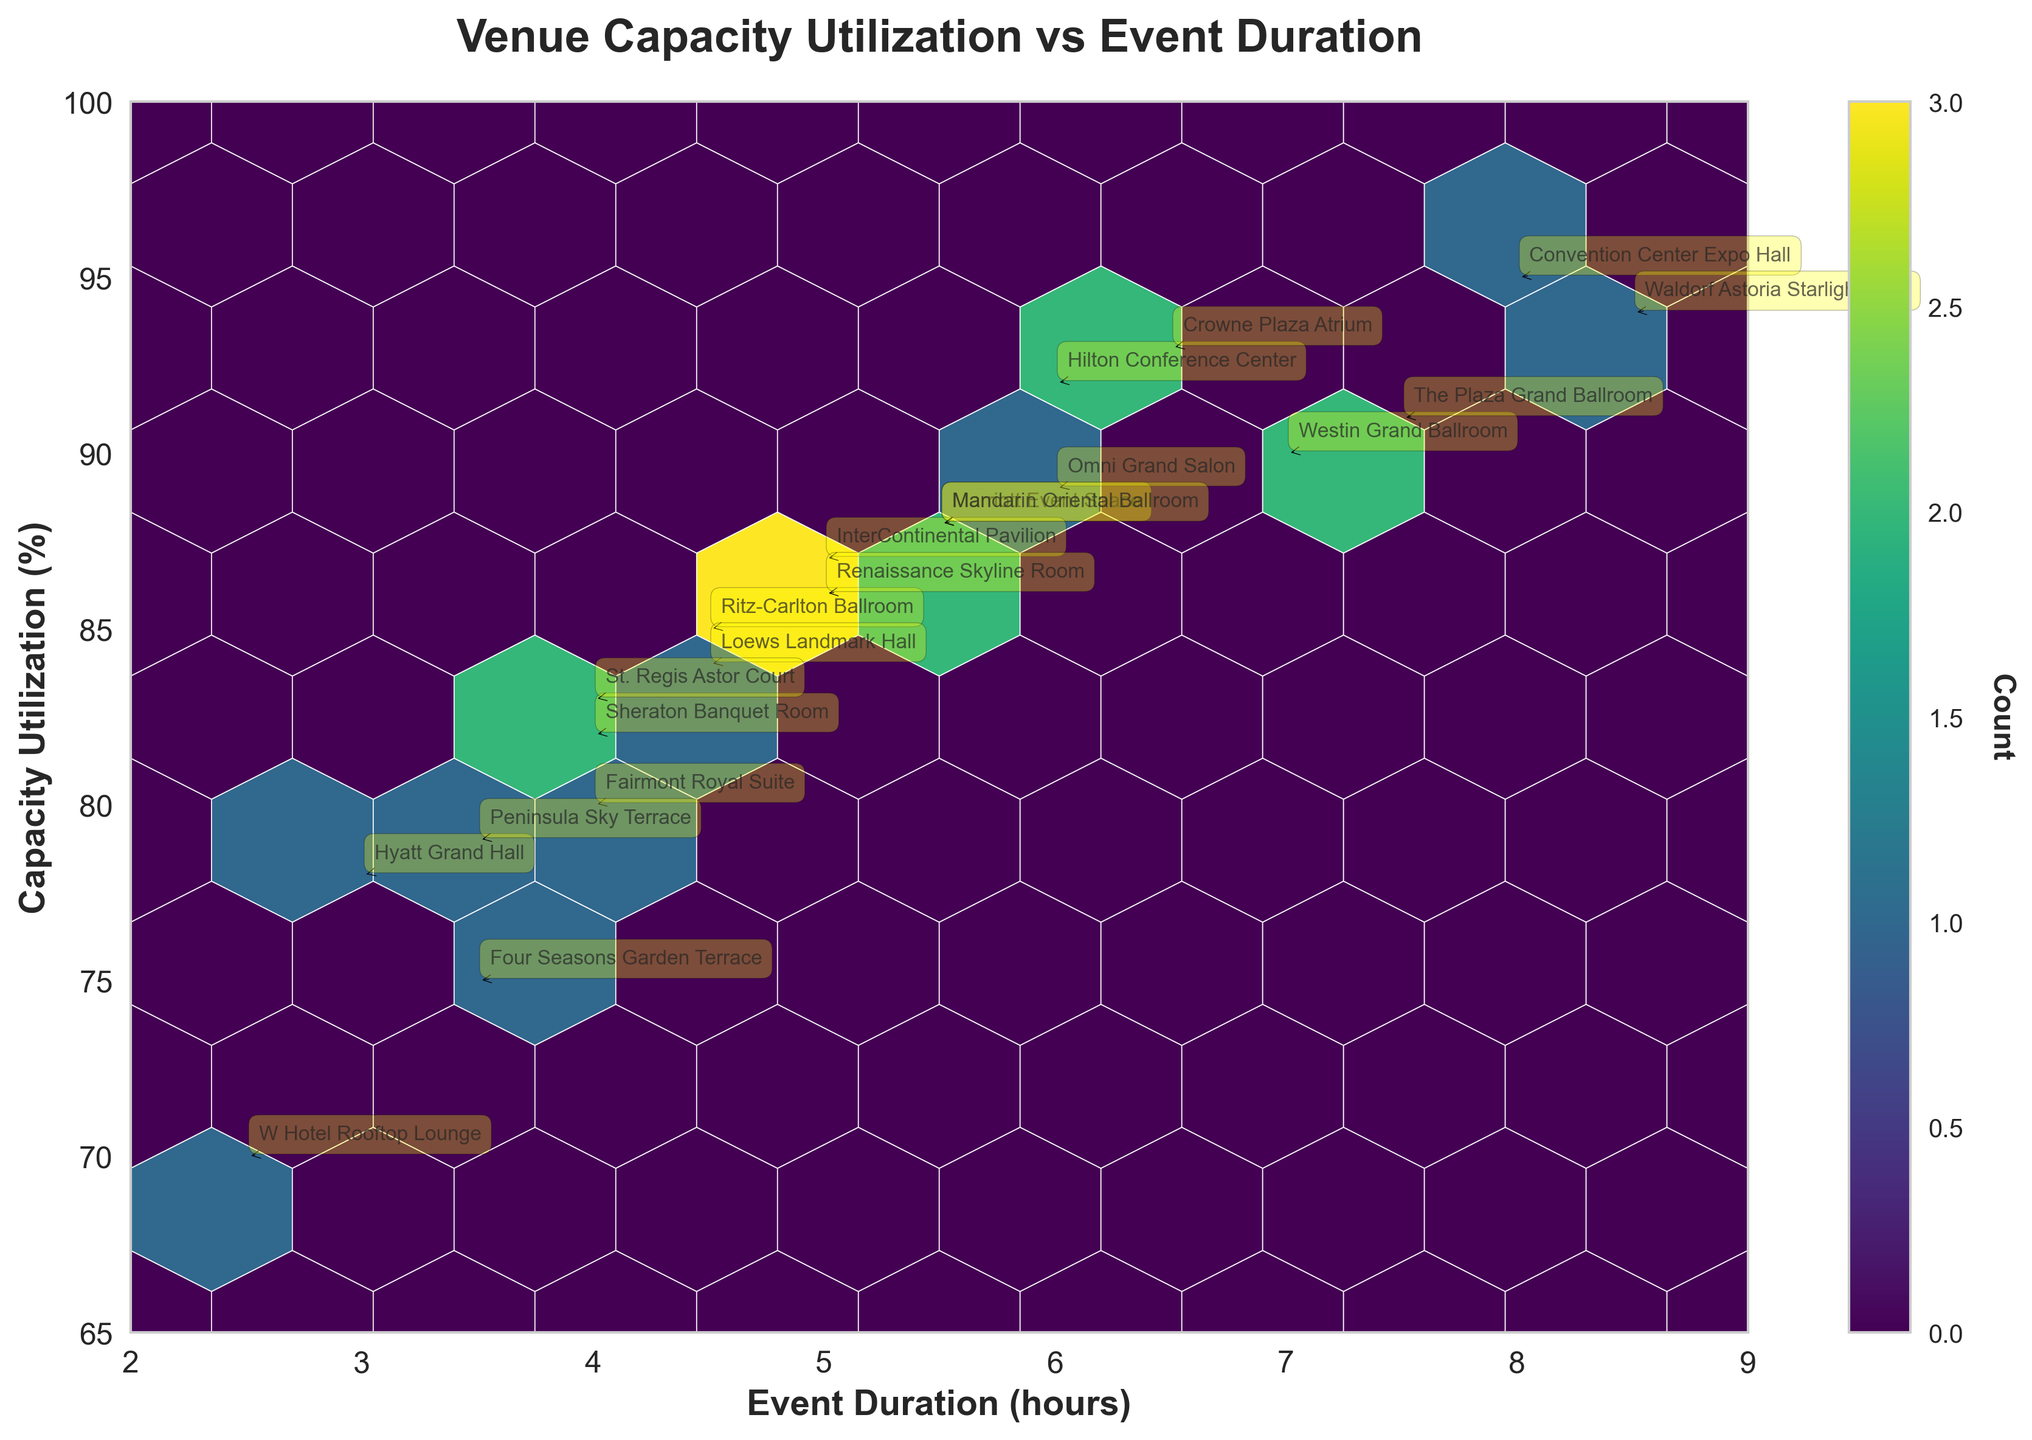What is the title of the figure? The title of the figure is typically displayed at the top. By looking at the top center of the plot, we can see the title clearly indicating the theme of the visualization.
Answer: Venue Capacity Utilization vs Event Duration What are the x-axis and y-axis labels? The axis labels provide context about the data being visualized. The x-axis is usually the horizontal axis, and the y-axis is the vertical axis. From the plot, the x-axis represents "Event Duration (hours)" and the y-axis represents "Capacity Utilization (%)".
Answer: Event Duration (hours), Capacity Utilization (%) How many hexbin bins display a count of 3 or more? Hexbin bins with a higher concentration of points will display a richer color based on the color map. We identify these bins by examining the color gradient and cross-referencing with the color bar.
Answer: 3 Which venue has the highest capacity utilization and what is its event duration? By identifying the data point with the highest capacity utilization on the y-axis, we look for the corresponding annotation to find the venue. The value on the x-axis gives us the event duration. The Waldorf Astoria Starlight Roof is at 94% and has an event duration of 8.5 hours.
Answer: Waldorf Astoria Starlight Roof, 8.5 hours Are there any venues with an event duration of less than 3 hours? By looking at the lower range of the x-axis (less than 3 hours), we check for any annotations within this segment.
Answer: Yes, W Hotel Rooftop Lounge What is the average capacity utilization for events with a duration of 6 hours? We find events that have a duration of 6 hours on the x-axis and check their capacity utilization on the y-axis. The venues are Hilton Conference Center (92%) and Omni Grand Salon (89%). We calculate the average of these two values: (92 + 89) / 2 = 90.5.
Answer: 90.5% Which venue has the shortest event duration and what is its capacity utilization? By identifying the data point with the shortest event duration on the x-axis, we refer to the corresponding annotation. The value on the y-axis represents capacity utilization. The W Hotel Rooftop Lounge has a duration of 2.5 hours and a capacity utilization of 70%.
Answer: W Hotel Rooftop Lounge, 70% Is there a trend of capacity utilization increasing with event duration? We examine the overall distribution of the data points in the plot. By visually assessing whether there is an upward pattern from the left to the right, we can infer if capacity utilization tends to increase with longer event durations.
Answer: No clear trend How many venues have a capacity utilization of over 90%? By looking at data points above the 90% mark on the y-axis, and counting the respective annotations present. The venues are Convention Center Expo Hall, Crowne Plaza Atrium, Hilton Conference Center, The Plaza Grand Ballroom, and Waldorf Astoria Starlight Roof.
Answer: 5 venues What is the difference in event duration between the venue with the highest and lowest capacity utilization? The highest capacity utilization is 94% (Waldorf Astoria Starlight Roof, 8.5 hours) and the lowest is 70% (W Hotel Rooftop Lounge, 2.5 hours). The difference in event duration is 8.5 - 2.5 = 6 hours.
Answer: 6 hours 